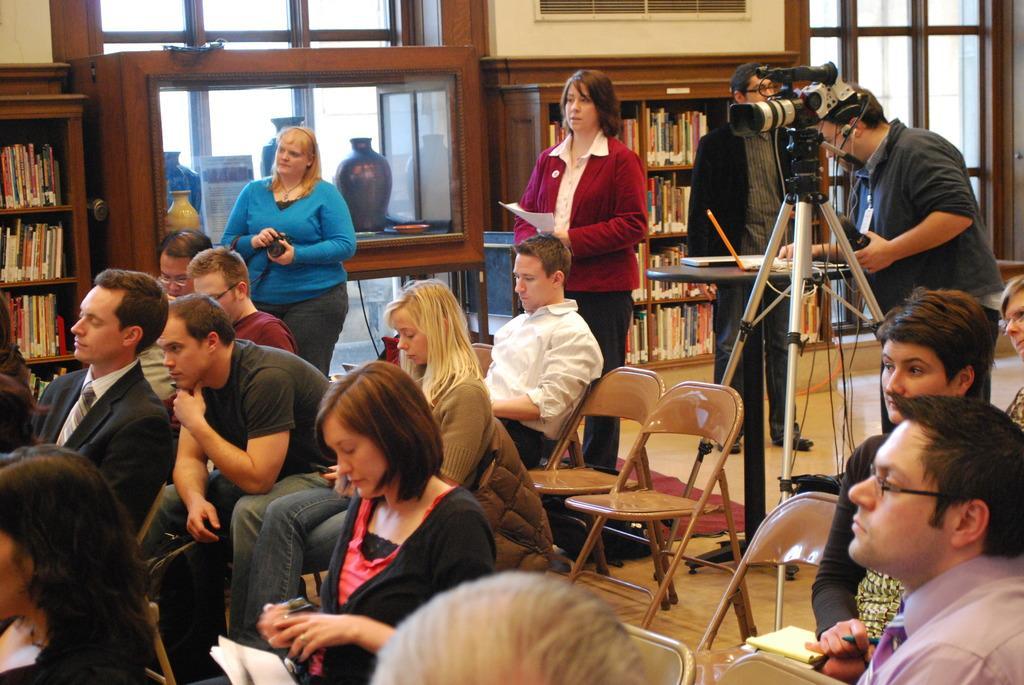Please provide a concise description of this image. there are many people in the room some people are sitting and some people are standing , a person is handling a video camera with a stand and a laptop which is on the table ,there are many shelves with a books on it. 